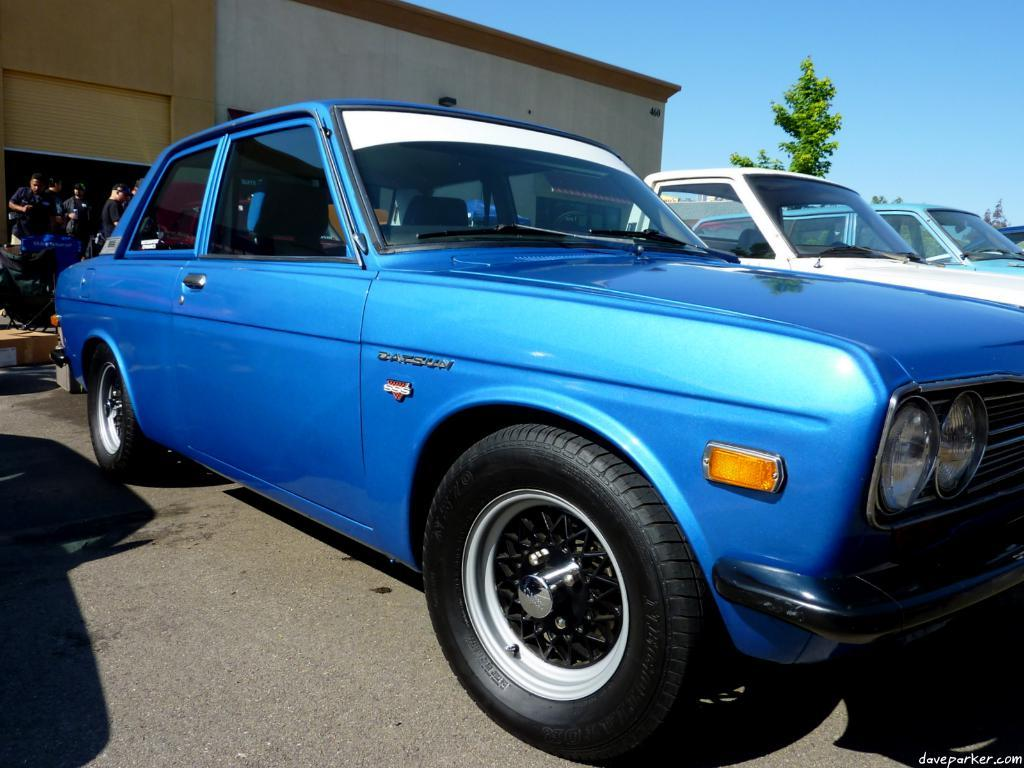What types of objects are present in the image? There are vehicles in the image. What can be seen in the background of the image? There is a building and trees visible behind the vehicles. Where are the persons located in the image? The persons are on the left side of the image. What is visible at the top of the image? The sky is visible at the top of the image. What type of wilderness can be seen in the image? There is no wilderness present in the image; it features vehicles, a building, trees, persons, and the sky. How does the image demonstrate respect for the environment? The image itself does not demonstrate respect for the environment, as it is a static representation of the scene. Respect for the environment is a behavioral concept and cannot be determined from the image. 